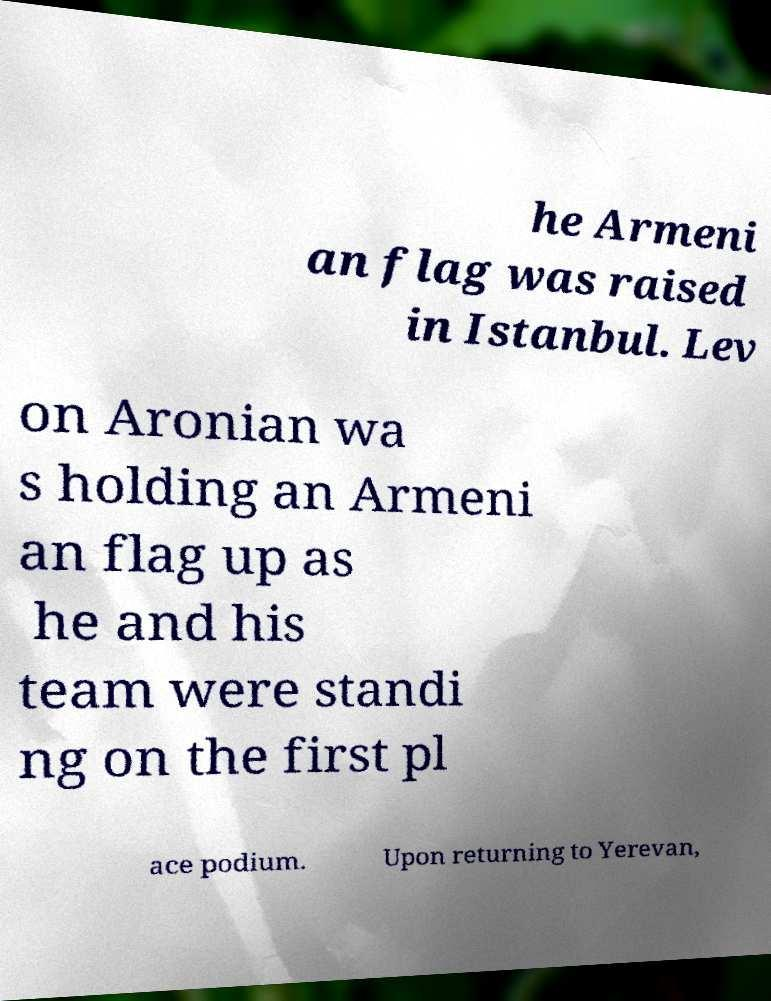Could you extract and type out the text from this image? he Armeni an flag was raised in Istanbul. Lev on Aronian wa s holding an Armeni an flag up as he and his team were standi ng on the first pl ace podium. Upon returning to Yerevan, 